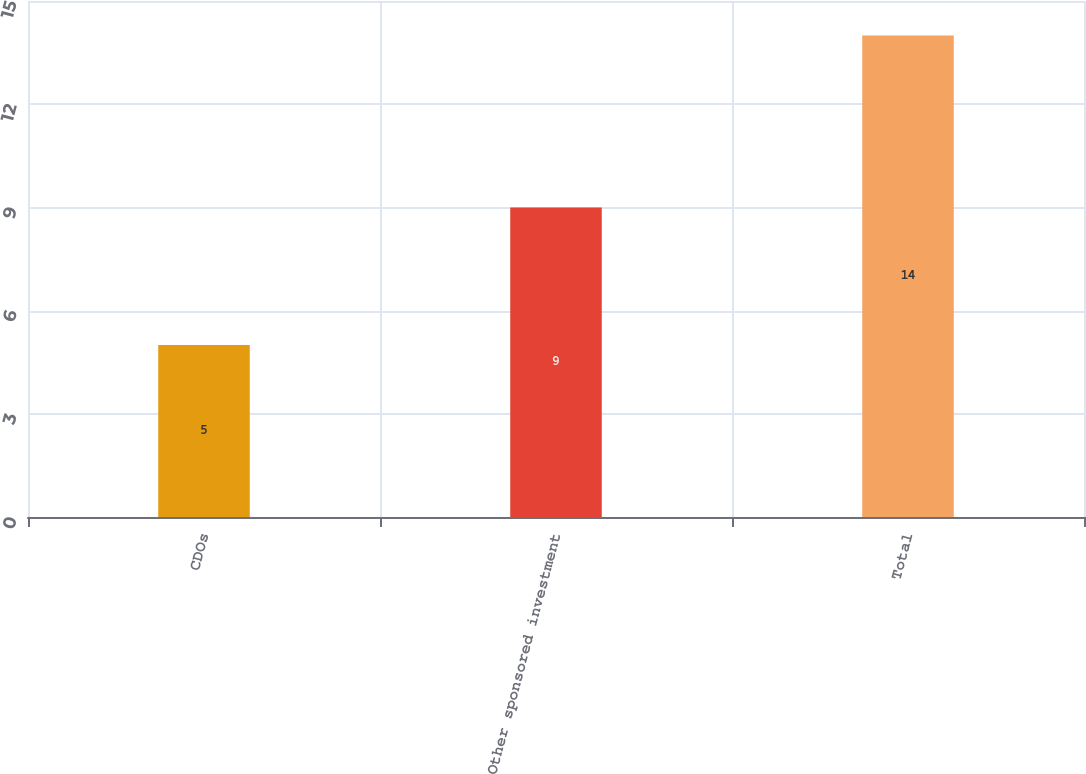Convert chart to OTSL. <chart><loc_0><loc_0><loc_500><loc_500><bar_chart><fcel>CDOs<fcel>Other sponsored investment<fcel>Total<nl><fcel>5<fcel>9<fcel>14<nl></chart> 